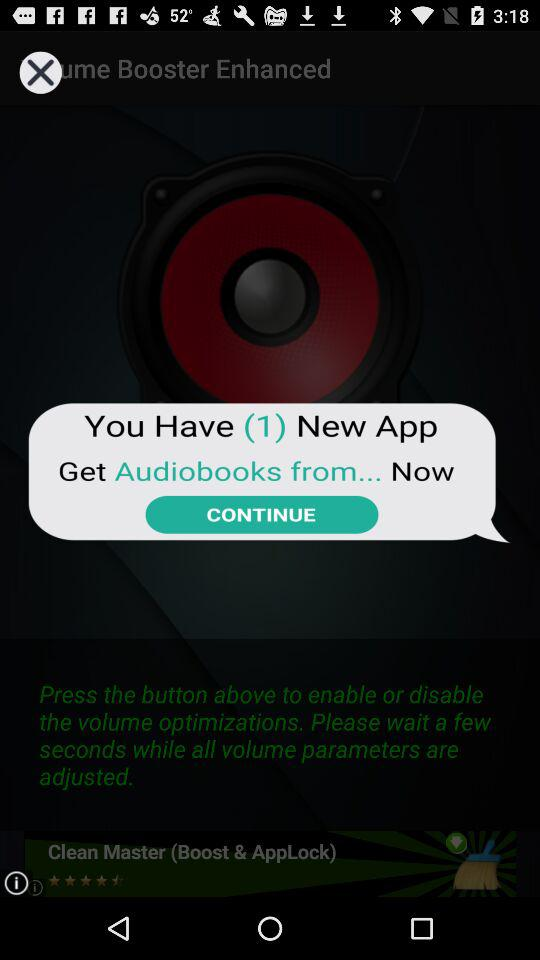Are there any new applications? There is 1 new application. 